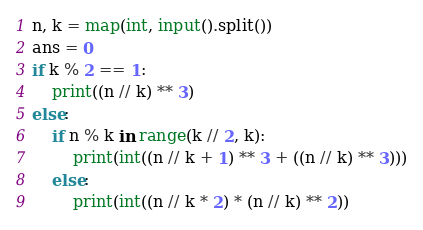<code> <loc_0><loc_0><loc_500><loc_500><_Python_>n, k = map(int, input().split())
ans = 0
if k % 2 == 1:
    print((n // k) ** 3)
else:
    if n % k in range(k // 2, k):
        print(int((n // k + 1) ** 3 + ((n // k) ** 3)))
    else:
        print(int((n // k * 2) * (n // k) ** 2))</code> 